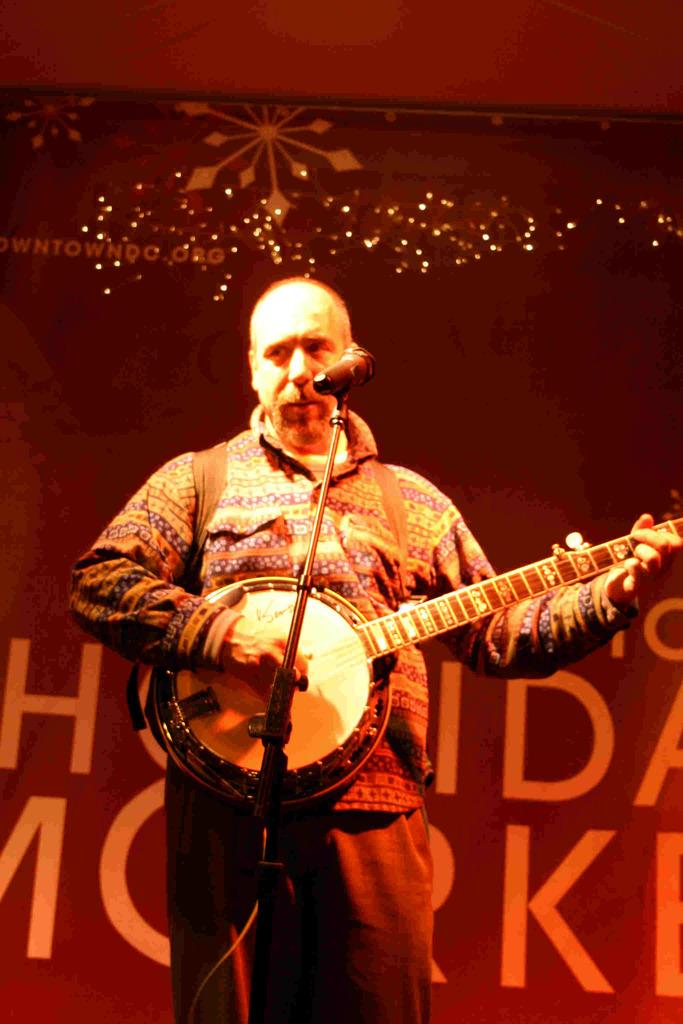What is the main subject of the image? The main subject of the image is a man. What is the man wearing? The man is wearing a shirt and trousers. What is the man holding in the image? The man is holding a musical instrument. What is the man's facial expression or focus in the image? The man is staring at something, suggesting he might be focused on a performance or audience. What is the context or setting of the image? The context suggests a possible stage performance. What type of hook can be seen on the man's shirt in the image? There is no hook visible on the man's shirt in the image. What word is written on the man's trousers in the image? There is no word visible on the man's trousers in the image. 